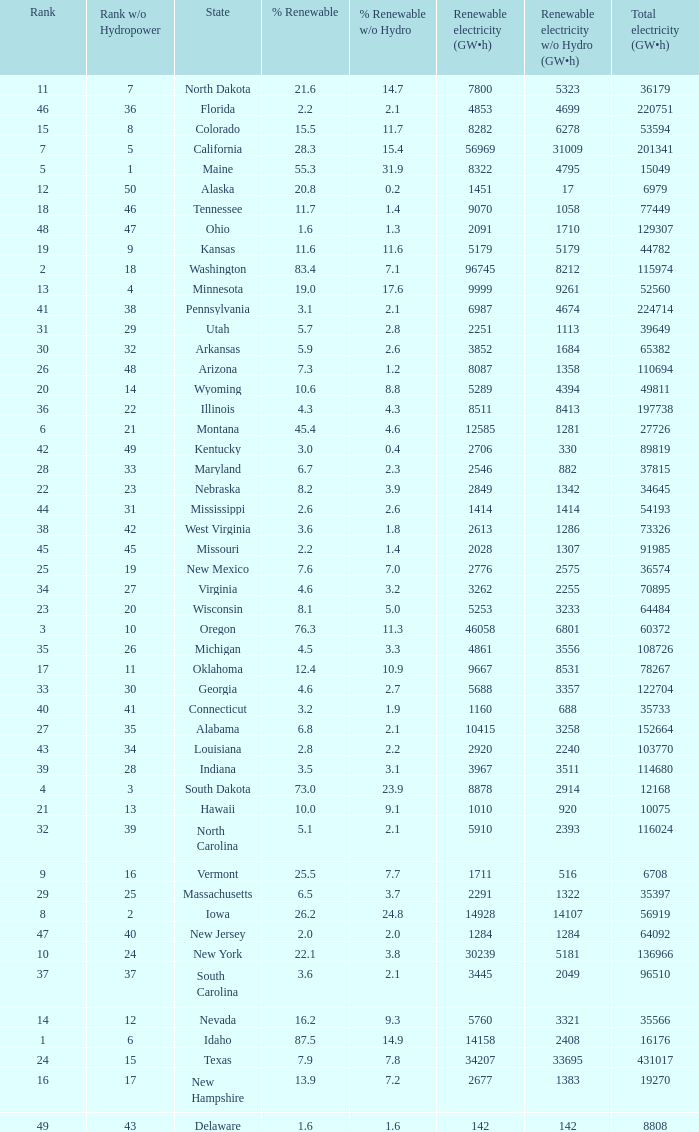Which states have renewable electricity equal to 9667 (gw×h)? Oklahoma. 